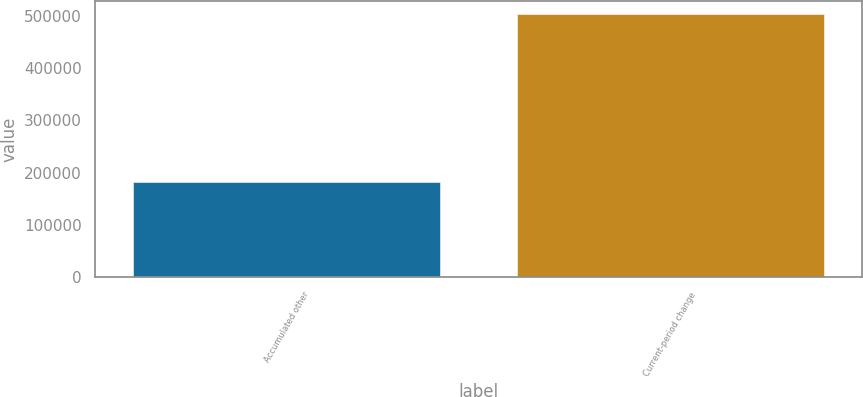Convert chart. <chart><loc_0><loc_0><loc_500><loc_500><bar_chart><fcel>Accumulated other<fcel>Current-period change<nl><fcel>182733<fcel>502669<nl></chart> 